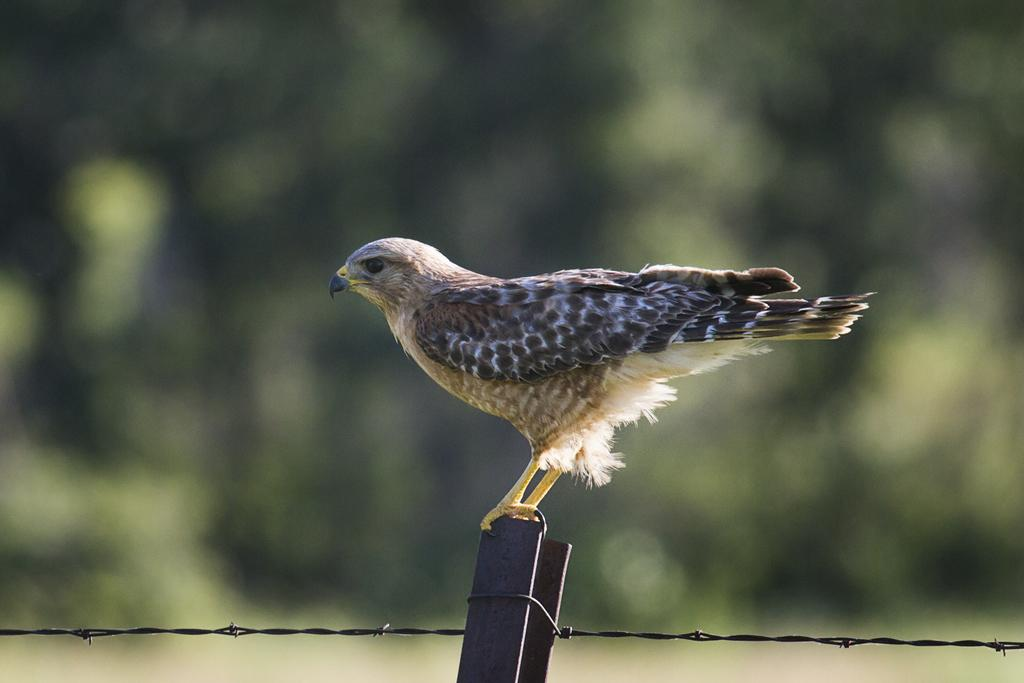What is the main subject of the image? The main subject of the image is a bird standing on a pole. What is located at the bottom of the image? Fencing is present at the bottom of the image. How would you describe the background of the image? The background of the image is blurry. How many beetles can be seen crawling on the rose in the image? There is no rose or beetles present in the image. 